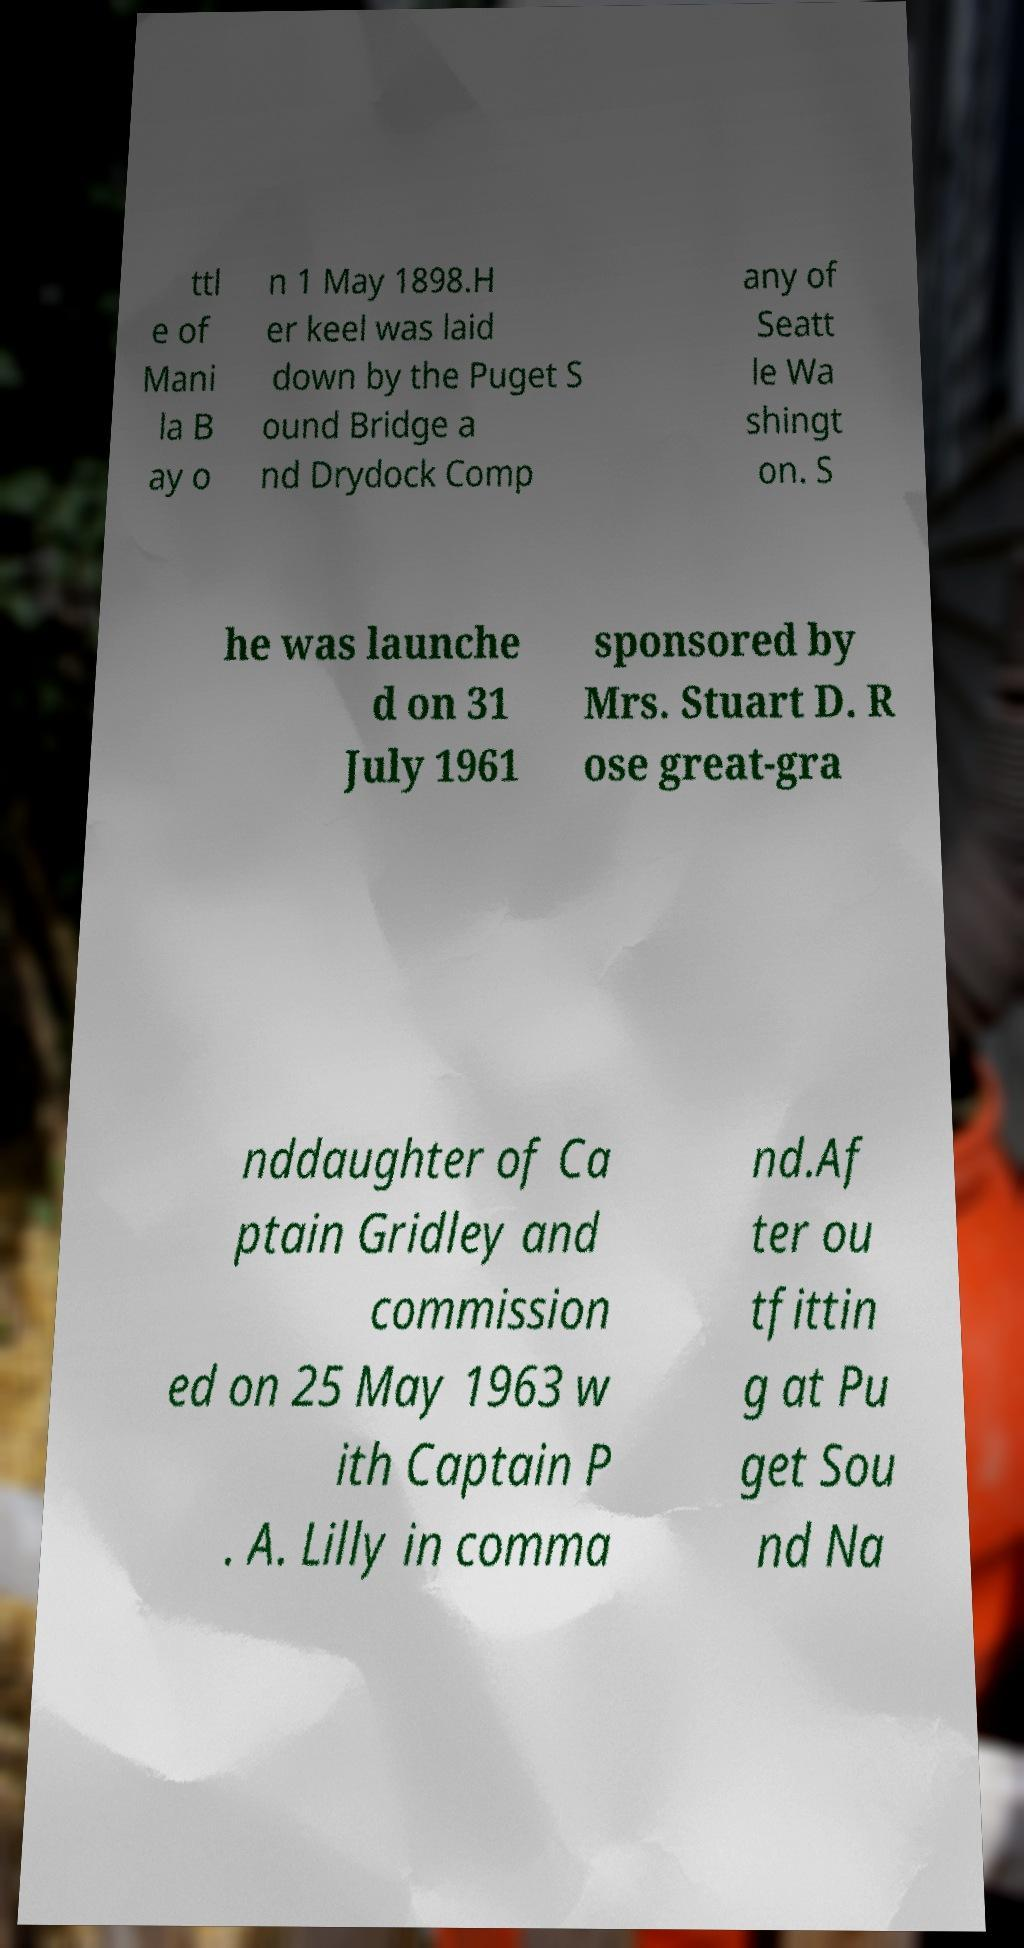Can you read and provide the text displayed in the image?This photo seems to have some interesting text. Can you extract and type it out for me? ttl e of Mani la B ay o n 1 May 1898.H er keel was laid down by the Puget S ound Bridge a nd Drydock Comp any of Seatt le Wa shingt on. S he was launche d on 31 July 1961 sponsored by Mrs. Stuart D. R ose great-gra nddaughter of Ca ptain Gridley and commission ed on 25 May 1963 w ith Captain P . A. Lilly in comma nd.Af ter ou tfittin g at Pu get Sou nd Na 